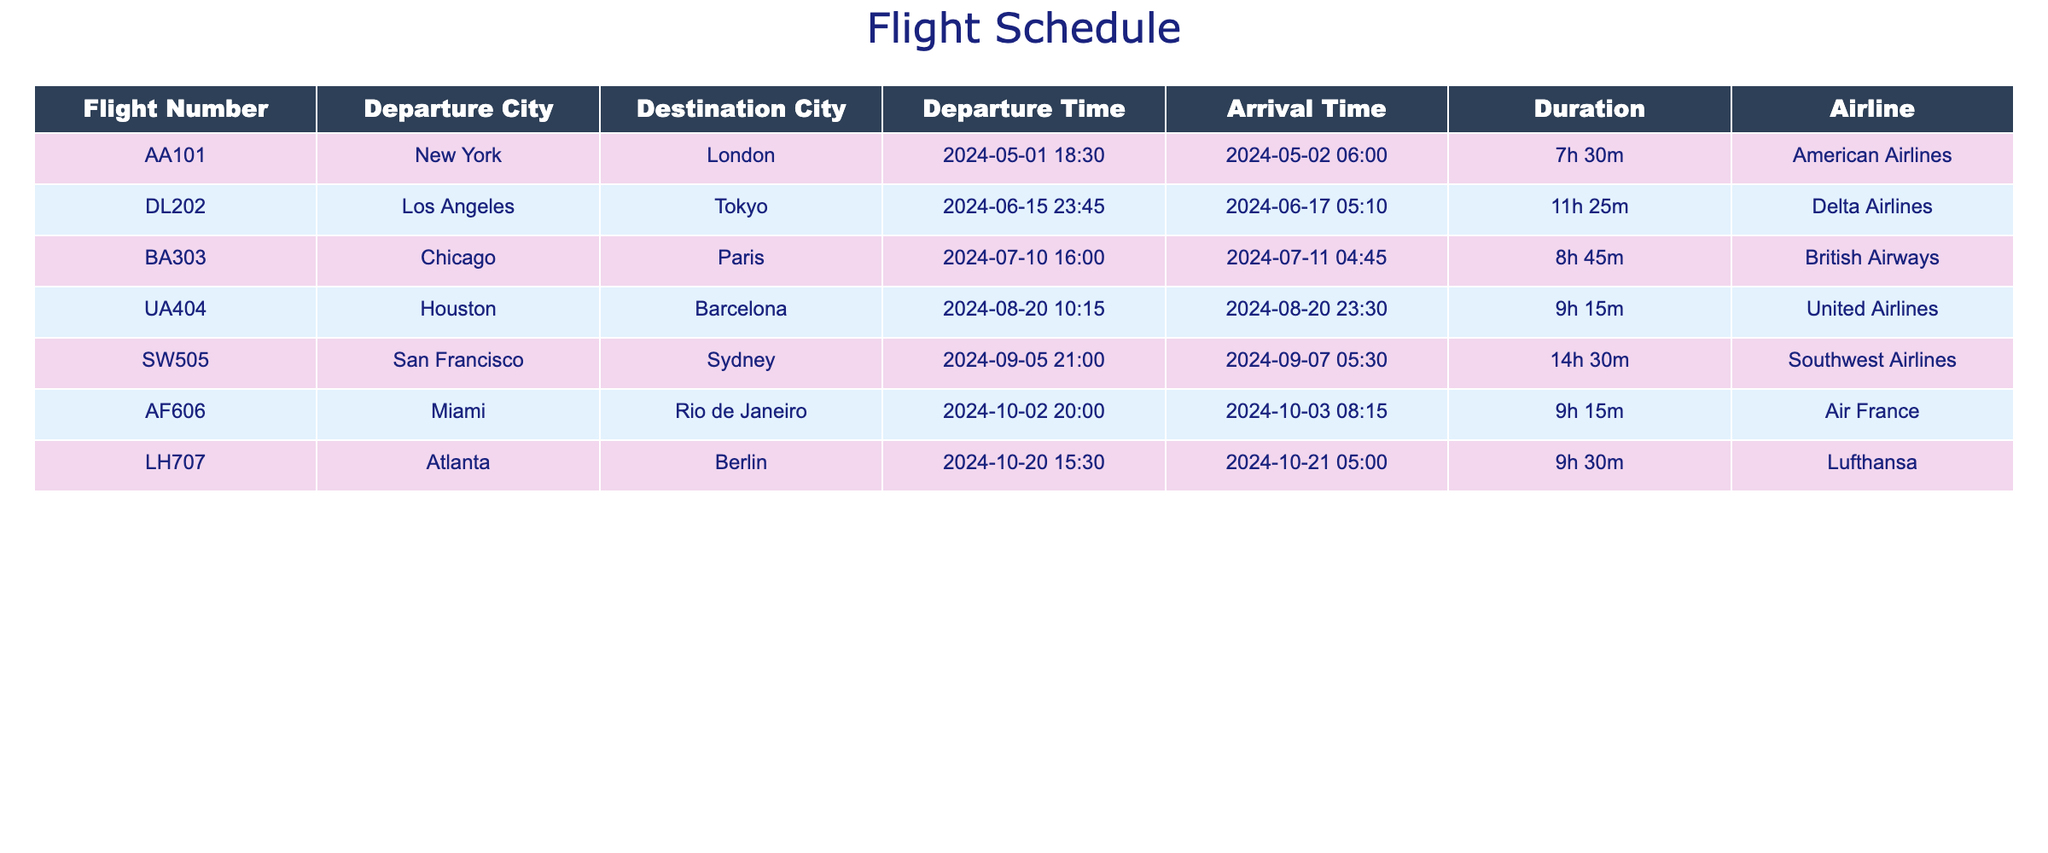What is the duration of the flight from Los Angeles to Tokyo? The flight from Los Angeles to Tokyo has a duration listed in the table as 11h 25m.
Answer: 11h 25m Which airline operates the flight from New York to London? The table indicates that the airline for the flight from New York to London is American Airlines.
Answer: American Airlines Is there a flight from Chicago to Paris? Yes, the table includes a flight number BA303 from Chicago to Paris.
Answer: Yes What is the departure time of the flight to Sydney? According to the table, the departure time for the flight to Sydney (from San Francisco) is 2024-09-05 at 21:00.
Answer: 2024-09-05 21:00 Which flight has the longest duration? The flight from San Francisco to Sydney has the longest duration listed at 14h 30m, while all others are shorter.
Answer: San Francisco to Sydney How many flights arrive after 5 AM? The flights from Tokyo, Paris, and Rio de Janeiro arrive after 5 AM, making a total of three flights that fit this criteria.
Answer: 3 What is the average duration of the flights listed? To find the average, we first need to convert each duration to hours, sum them (7.5 + 11.42 + 8.75 + 9.25 + 14.5 + 9.25 + 9.5) = 69.67 hours. Dividing by the number of flights (7) gives us an average duration of approximately 9.95 hours.
Answer: 9.95 hours Is the flight from Houston to Barcelona shorter than the flight from Chicago to Paris? Comparing the durations, the Houston to Barcelona flight is 9h 15m, while the Chicago to Paris flight is 8h 45m, thus the flight from Barcelona is longer.
Answer: No What time does the flight from Miami to Rio de Janeiro arrive? The flight from Miami to Rio de Janeiro arrives on 2024-10-03 at 08:15, as shown in the table.
Answer: 2024-10-03 08:15 